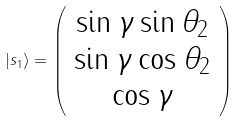Convert formula to latex. <formula><loc_0><loc_0><loc_500><loc_500>| s _ { 1 } \rangle = \left ( \begin{array} { c } \sin \gamma \sin \theta _ { 2 } \\ \sin \gamma \cos \theta _ { 2 } \\ \cos \gamma \end{array} \right )</formula> 